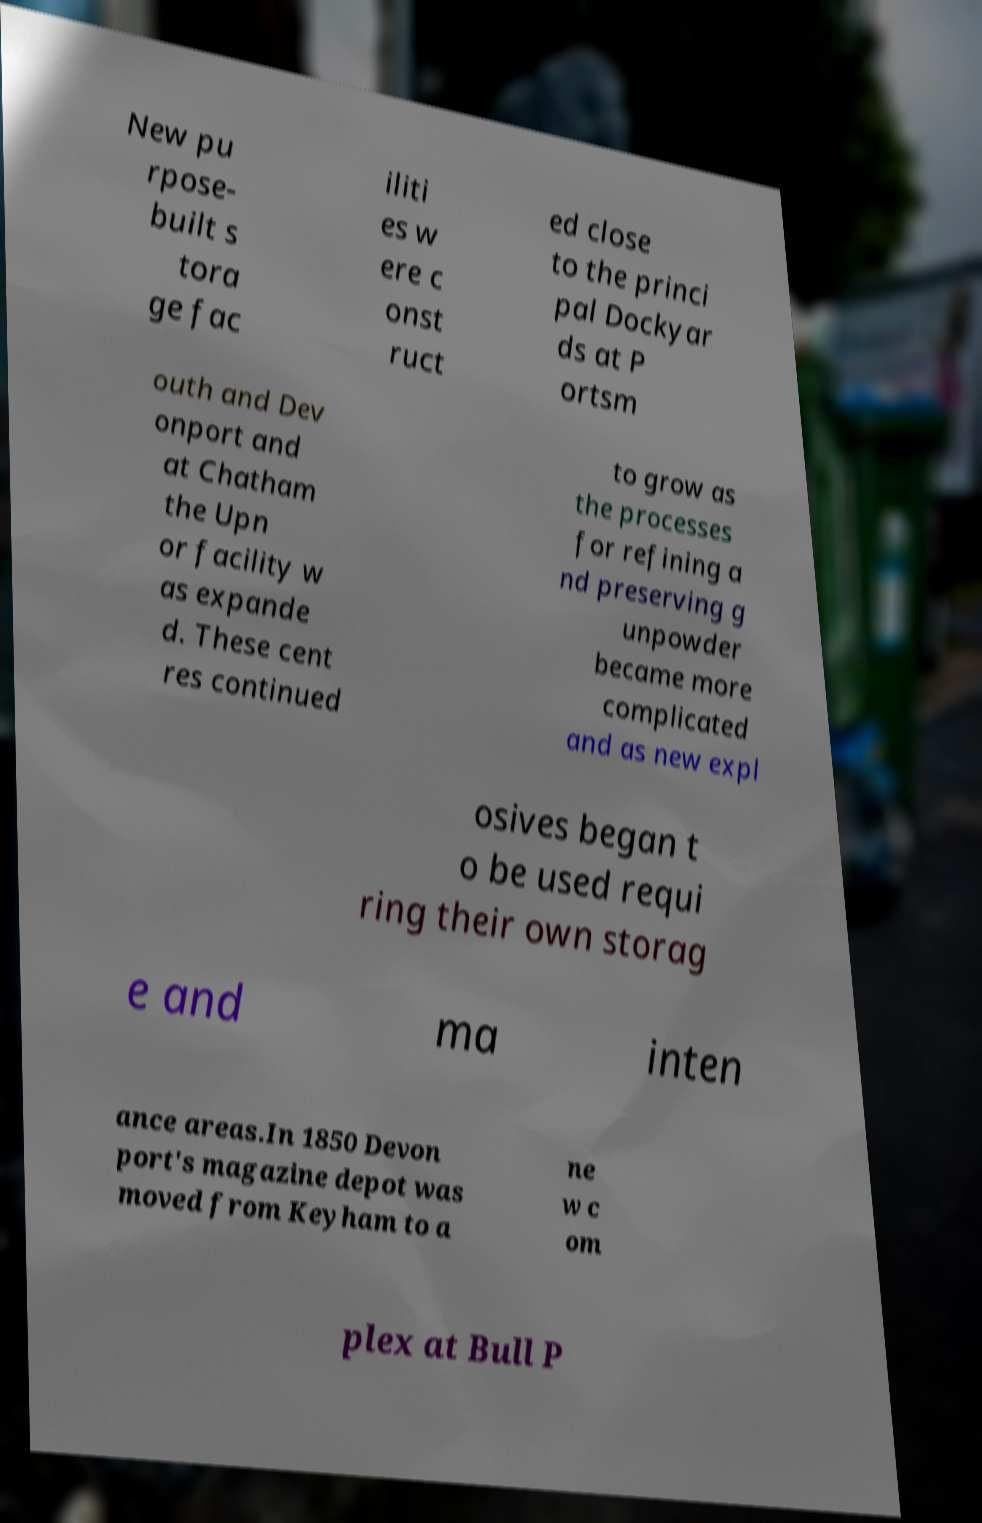Please read and relay the text visible in this image. What does it say? New pu rpose- built s tora ge fac iliti es w ere c onst ruct ed close to the princi pal Dockyar ds at P ortsm outh and Dev onport and at Chatham the Upn or facility w as expande d. These cent res continued to grow as the processes for refining a nd preserving g unpowder became more complicated and as new expl osives began t o be used requi ring their own storag e and ma inten ance areas.In 1850 Devon port's magazine depot was moved from Keyham to a ne w c om plex at Bull P 